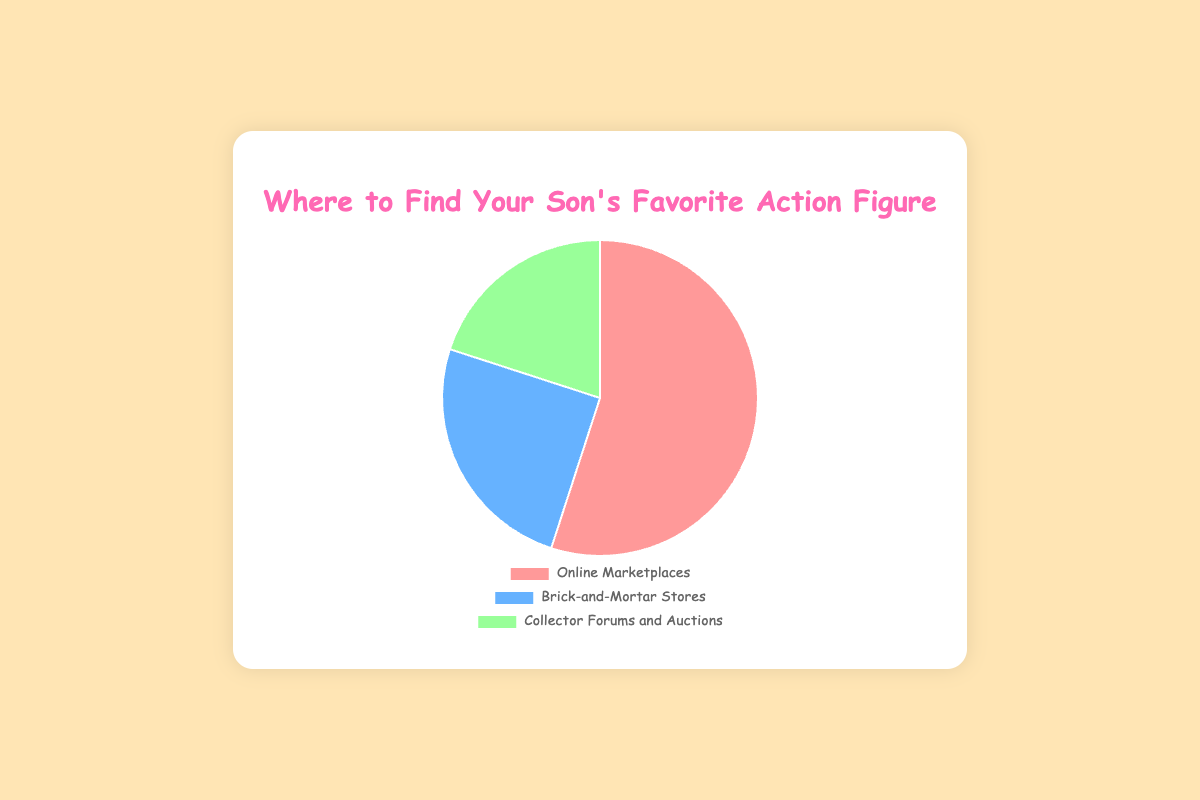Where can I most likely find my son's favorite action figure? To determine the most likely location, refer to the largest section of the pie chart. "Online Marketplaces" (represented by eBay) is the largest with 55%.
Answer: Online Marketplaces Which platform has the smallest percentage for finding the action figure? Compare the percentages of the three platforms: eBay (55%), Local Toy Shops (25%), and ToyCon Auctions (20%). The smallest percentage is ToyCon Auctions with 20%.
Answer: ToyCon Auctions What is the combined percentage of offline sources for finding the action figure? Sum the percentages of "Brick-and-Mortar Stores" (Local Toy Shops) and "Collector Forums and Auctions" (ToyCon Auctions). That is 25% + 20% = 45%.
Answer: 45% Is the percentage for Online Marketplaces greater than both Brick-and-Mortar Stores and Collector Forums and Auctions combined? Add the percentages of "Brick-and-Mortar Stores" and "Collector Forums and Auctions" (25% + 20% = 45%). Compare this to the "Online Marketplaces" percentage of 55%. Yes, 55% is greater than 45%.
Answer: Yes Which section of the pie chart is represented in blue? Identify the color segments in the pie chart associated with their labels. "Brick-and-Mortar Stores" is represented in blue.
Answer: Brick-and-Mortar Stores How much larger is the percentage for Online Marketplaces compared to Collector Forums and Auctions? Subtract the percentage of "Collector Forums and Auctions" (20%) from "Online Marketplaces" (55%). 55% - 20% = 35%.
Answer: 35% What is the average percentage of all three platforms for finding the action figure? Add all the percentages and divide by three: (55% + 25% + 20%) / 3 = 100% / 3 ≈ 33.33%.
Answer: 33.33% If I prefer offline shopping, which option should I consider first? Within the offline categories, compare "Brick-and-Mortar Stores" (25%) and "Collector Forums and Auctions" (20%). The larger percentage is "Brick-and-Mortar Stores".
Answer: Brick-and-Mortar Stores 